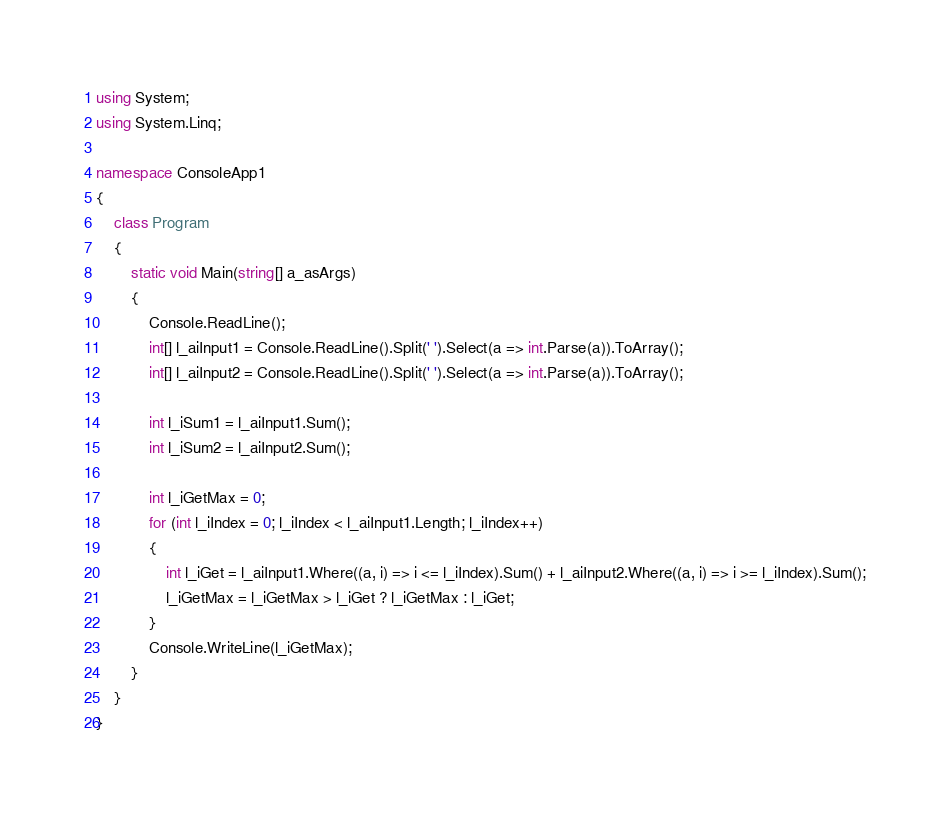Convert code to text. <code><loc_0><loc_0><loc_500><loc_500><_C#_>using System;
using System.Linq;

namespace ConsoleApp1
{
    class Program
    {
        static void Main(string[] a_asArgs)
        {
			Console.ReadLine();
			int[] l_aiInput1 = Console.ReadLine().Split(' ').Select(a => int.Parse(a)).ToArray();
			int[] l_aiInput2 = Console.ReadLine().Split(' ').Select(a => int.Parse(a)).ToArray();

			int l_iSum1 = l_aiInput1.Sum();
			int l_iSum2 = l_aiInput2.Sum();

			int l_iGetMax = 0;
			for (int l_iIndex = 0; l_iIndex < l_aiInput1.Length; l_iIndex++)
			{
				int l_iGet = l_aiInput1.Where((a, i) => i <= l_iIndex).Sum() + l_aiInput2.Where((a, i) => i >= l_iIndex).Sum();
				l_iGetMax = l_iGetMax > l_iGet ? l_iGetMax : l_iGet;
			}
			Console.WriteLine(l_iGetMax);
		}
	}
}
</code> 